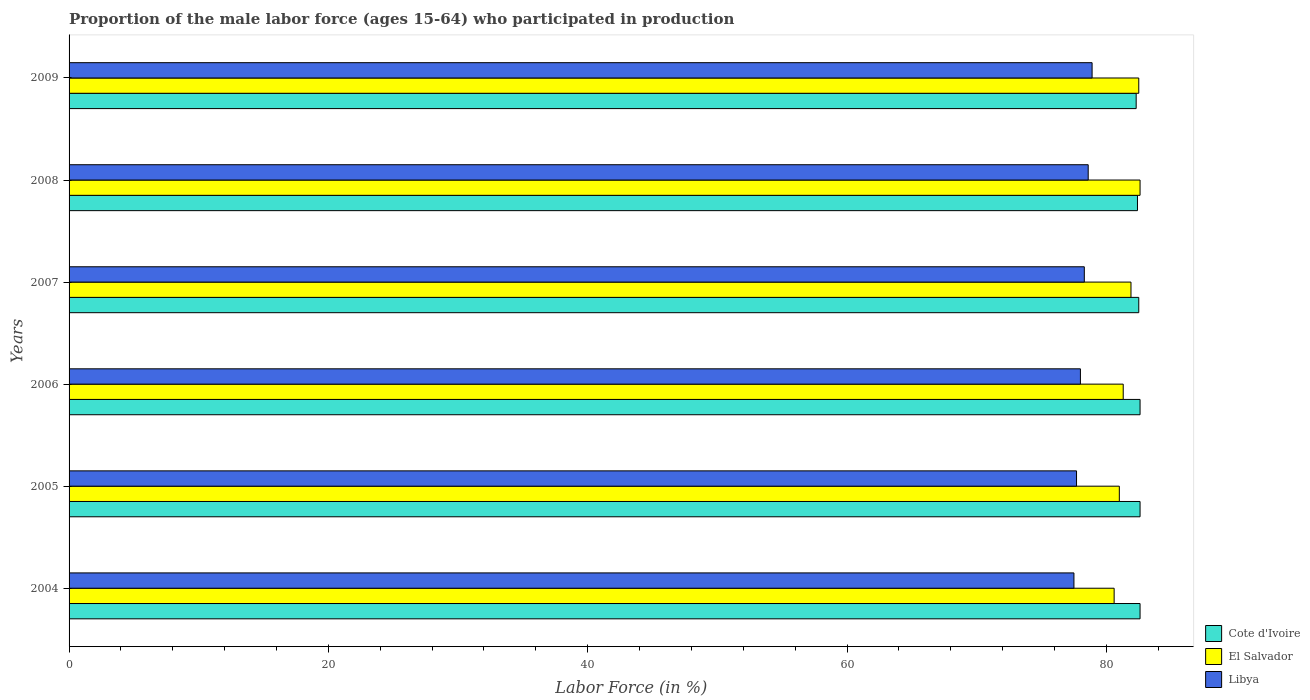How many groups of bars are there?
Give a very brief answer. 6. What is the label of the 4th group of bars from the top?
Offer a very short reply. 2006. What is the proportion of the male labor force who participated in production in Libya in 2008?
Your answer should be compact. 78.6. Across all years, what is the maximum proportion of the male labor force who participated in production in El Salvador?
Give a very brief answer. 82.6. Across all years, what is the minimum proportion of the male labor force who participated in production in Libya?
Your response must be concise. 77.5. In which year was the proportion of the male labor force who participated in production in Cote d'Ivoire minimum?
Offer a terse response. 2009. What is the total proportion of the male labor force who participated in production in Libya in the graph?
Provide a succinct answer. 469. What is the difference between the proportion of the male labor force who participated in production in Cote d'Ivoire in 2005 and that in 2008?
Your response must be concise. 0.2. What is the difference between the proportion of the male labor force who participated in production in El Salvador in 2005 and the proportion of the male labor force who participated in production in Libya in 2007?
Provide a short and direct response. 2.7. What is the average proportion of the male labor force who participated in production in El Salvador per year?
Ensure brevity in your answer.  81.65. In the year 2006, what is the difference between the proportion of the male labor force who participated in production in El Salvador and proportion of the male labor force who participated in production in Libya?
Give a very brief answer. 3.3. In how many years, is the proportion of the male labor force who participated in production in Libya greater than 48 %?
Offer a very short reply. 6. What is the ratio of the proportion of the male labor force who participated in production in Libya in 2006 to that in 2008?
Keep it short and to the point. 0.99. Is the proportion of the male labor force who participated in production in El Salvador in 2004 less than that in 2005?
Provide a short and direct response. Yes. What is the difference between the highest and the second highest proportion of the male labor force who participated in production in El Salvador?
Your response must be concise. 0.1. What is the difference between the highest and the lowest proportion of the male labor force who participated in production in Libya?
Make the answer very short. 1.4. In how many years, is the proportion of the male labor force who participated in production in Libya greater than the average proportion of the male labor force who participated in production in Libya taken over all years?
Give a very brief answer. 3. Is the sum of the proportion of the male labor force who participated in production in Libya in 2005 and 2007 greater than the maximum proportion of the male labor force who participated in production in El Salvador across all years?
Offer a very short reply. Yes. What does the 3rd bar from the top in 2006 represents?
Make the answer very short. Cote d'Ivoire. What does the 2nd bar from the bottom in 2007 represents?
Your answer should be compact. El Salvador. Is it the case that in every year, the sum of the proportion of the male labor force who participated in production in El Salvador and proportion of the male labor force who participated in production in Libya is greater than the proportion of the male labor force who participated in production in Cote d'Ivoire?
Your answer should be compact. Yes. Are all the bars in the graph horizontal?
Make the answer very short. Yes. How many years are there in the graph?
Ensure brevity in your answer.  6. Are the values on the major ticks of X-axis written in scientific E-notation?
Your response must be concise. No. Where does the legend appear in the graph?
Provide a short and direct response. Bottom right. How are the legend labels stacked?
Give a very brief answer. Vertical. What is the title of the graph?
Offer a very short reply. Proportion of the male labor force (ages 15-64) who participated in production. What is the label or title of the Y-axis?
Ensure brevity in your answer.  Years. What is the Labor Force (in %) of Cote d'Ivoire in 2004?
Ensure brevity in your answer.  82.6. What is the Labor Force (in %) in El Salvador in 2004?
Your response must be concise. 80.6. What is the Labor Force (in %) of Libya in 2004?
Ensure brevity in your answer.  77.5. What is the Labor Force (in %) of Cote d'Ivoire in 2005?
Your response must be concise. 82.6. What is the Labor Force (in %) of Libya in 2005?
Your answer should be very brief. 77.7. What is the Labor Force (in %) in Cote d'Ivoire in 2006?
Your answer should be compact. 82.6. What is the Labor Force (in %) of El Salvador in 2006?
Provide a succinct answer. 81.3. What is the Labor Force (in %) in Cote d'Ivoire in 2007?
Ensure brevity in your answer.  82.5. What is the Labor Force (in %) of El Salvador in 2007?
Offer a very short reply. 81.9. What is the Labor Force (in %) of Libya in 2007?
Provide a short and direct response. 78.3. What is the Labor Force (in %) in Cote d'Ivoire in 2008?
Provide a succinct answer. 82.4. What is the Labor Force (in %) of El Salvador in 2008?
Offer a terse response. 82.6. What is the Labor Force (in %) in Libya in 2008?
Offer a very short reply. 78.6. What is the Labor Force (in %) in Cote d'Ivoire in 2009?
Provide a succinct answer. 82.3. What is the Labor Force (in %) of El Salvador in 2009?
Your answer should be compact. 82.5. What is the Labor Force (in %) of Libya in 2009?
Give a very brief answer. 78.9. Across all years, what is the maximum Labor Force (in %) in Cote d'Ivoire?
Your answer should be very brief. 82.6. Across all years, what is the maximum Labor Force (in %) in El Salvador?
Your answer should be very brief. 82.6. Across all years, what is the maximum Labor Force (in %) in Libya?
Offer a terse response. 78.9. Across all years, what is the minimum Labor Force (in %) in Cote d'Ivoire?
Offer a terse response. 82.3. Across all years, what is the minimum Labor Force (in %) in El Salvador?
Provide a short and direct response. 80.6. Across all years, what is the minimum Labor Force (in %) in Libya?
Keep it short and to the point. 77.5. What is the total Labor Force (in %) in Cote d'Ivoire in the graph?
Provide a short and direct response. 495. What is the total Labor Force (in %) of El Salvador in the graph?
Provide a short and direct response. 489.9. What is the total Labor Force (in %) of Libya in the graph?
Keep it short and to the point. 469. What is the difference between the Labor Force (in %) of El Salvador in 2004 and that in 2006?
Your response must be concise. -0.7. What is the difference between the Labor Force (in %) of Libya in 2004 and that in 2006?
Ensure brevity in your answer.  -0.5. What is the difference between the Labor Force (in %) of El Salvador in 2004 and that in 2007?
Provide a short and direct response. -1.3. What is the difference between the Labor Force (in %) of Libya in 2004 and that in 2007?
Offer a terse response. -0.8. What is the difference between the Labor Force (in %) in Cote d'Ivoire in 2004 and that in 2008?
Offer a very short reply. 0.2. What is the difference between the Labor Force (in %) in Libya in 2004 and that in 2008?
Make the answer very short. -1.1. What is the difference between the Labor Force (in %) of Cote d'Ivoire in 2004 and that in 2009?
Your answer should be compact. 0.3. What is the difference between the Labor Force (in %) of El Salvador in 2004 and that in 2009?
Make the answer very short. -1.9. What is the difference between the Labor Force (in %) in Libya in 2004 and that in 2009?
Give a very brief answer. -1.4. What is the difference between the Labor Force (in %) of Cote d'Ivoire in 2005 and that in 2006?
Offer a terse response. 0. What is the difference between the Labor Force (in %) in Libya in 2005 and that in 2006?
Provide a short and direct response. -0.3. What is the difference between the Labor Force (in %) in Cote d'Ivoire in 2005 and that in 2007?
Make the answer very short. 0.1. What is the difference between the Labor Force (in %) of El Salvador in 2005 and that in 2007?
Give a very brief answer. -0.9. What is the difference between the Labor Force (in %) in Libya in 2005 and that in 2007?
Ensure brevity in your answer.  -0.6. What is the difference between the Labor Force (in %) in Cote d'Ivoire in 2005 and that in 2008?
Your response must be concise. 0.2. What is the difference between the Labor Force (in %) in El Salvador in 2005 and that in 2008?
Offer a very short reply. -1.6. What is the difference between the Labor Force (in %) in Libya in 2005 and that in 2008?
Offer a very short reply. -0.9. What is the difference between the Labor Force (in %) of El Salvador in 2005 and that in 2009?
Your response must be concise. -1.5. What is the difference between the Labor Force (in %) of Libya in 2006 and that in 2007?
Make the answer very short. -0.3. What is the difference between the Labor Force (in %) of El Salvador in 2006 and that in 2008?
Make the answer very short. -1.3. What is the difference between the Labor Force (in %) of Cote d'Ivoire in 2006 and that in 2009?
Give a very brief answer. 0.3. What is the difference between the Labor Force (in %) in El Salvador in 2006 and that in 2009?
Give a very brief answer. -1.2. What is the difference between the Labor Force (in %) of Cote d'Ivoire in 2007 and that in 2008?
Make the answer very short. 0.1. What is the difference between the Labor Force (in %) of El Salvador in 2007 and that in 2009?
Make the answer very short. -0.6. What is the difference between the Labor Force (in %) of Libya in 2007 and that in 2009?
Offer a terse response. -0.6. What is the difference between the Labor Force (in %) in Cote d'Ivoire in 2008 and that in 2009?
Provide a short and direct response. 0.1. What is the difference between the Labor Force (in %) of Libya in 2008 and that in 2009?
Ensure brevity in your answer.  -0.3. What is the difference between the Labor Force (in %) of Cote d'Ivoire in 2004 and the Labor Force (in %) of El Salvador in 2005?
Make the answer very short. 1.6. What is the difference between the Labor Force (in %) of Cote d'Ivoire in 2004 and the Labor Force (in %) of Libya in 2005?
Give a very brief answer. 4.9. What is the difference between the Labor Force (in %) in El Salvador in 2004 and the Labor Force (in %) in Libya in 2005?
Your response must be concise. 2.9. What is the difference between the Labor Force (in %) in Cote d'Ivoire in 2004 and the Labor Force (in %) in El Salvador in 2006?
Provide a succinct answer. 1.3. What is the difference between the Labor Force (in %) of El Salvador in 2004 and the Labor Force (in %) of Libya in 2006?
Make the answer very short. 2.6. What is the difference between the Labor Force (in %) of Cote d'Ivoire in 2004 and the Labor Force (in %) of El Salvador in 2007?
Make the answer very short. 0.7. What is the difference between the Labor Force (in %) in Cote d'Ivoire in 2004 and the Labor Force (in %) in Libya in 2007?
Ensure brevity in your answer.  4.3. What is the difference between the Labor Force (in %) of El Salvador in 2004 and the Labor Force (in %) of Libya in 2007?
Offer a terse response. 2.3. What is the difference between the Labor Force (in %) of Cote d'Ivoire in 2004 and the Labor Force (in %) of El Salvador in 2008?
Offer a terse response. 0. What is the difference between the Labor Force (in %) of El Salvador in 2004 and the Labor Force (in %) of Libya in 2008?
Offer a terse response. 2. What is the difference between the Labor Force (in %) in Cote d'Ivoire in 2004 and the Labor Force (in %) in El Salvador in 2009?
Provide a succinct answer. 0.1. What is the difference between the Labor Force (in %) of El Salvador in 2004 and the Labor Force (in %) of Libya in 2009?
Give a very brief answer. 1.7. What is the difference between the Labor Force (in %) in Cote d'Ivoire in 2005 and the Labor Force (in %) in El Salvador in 2006?
Provide a short and direct response. 1.3. What is the difference between the Labor Force (in %) in Cote d'Ivoire in 2005 and the Labor Force (in %) in Libya in 2008?
Keep it short and to the point. 4. What is the difference between the Labor Force (in %) of Cote d'Ivoire in 2005 and the Labor Force (in %) of Libya in 2009?
Provide a short and direct response. 3.7. What is the difference between the Labor Force (in %) of Cote d'Ivoire in 2006 and the Labor Force (in %) of El Salvador in 2007?
Keep it short and to the point. 0.7. What is the difference between the Labor Force (in %) of Cote d'Ivoire in 2006 and the Labor Force (in %) of El Salvador in 2008?
Keep it short and to the point. 0. What is the difference between the Labor Force (in %) of El Salvador in 2006 and the Labor Force (in %) of Libya in 2008?
Ensure brevity in your answer.  2.7. What is the difference between the Labor Force (in %) of Cote d'Ivoire in 2006 and the Labor Force (in %) of Libya in 2009?
Ensure brevity in your answer.  3.7. What is the difference between the Labor Force (in %) in Cote d'Ivoire in 2007 and the Labor Force (in %) in El Salvador in 2008?
Your response must be concise. -0.1. What is the difference between the Labor Force (in %) of Cote d'Ivoire in 2007 and the Labor Force (in %) of Libya in 2008?
Offer a terse response. 3.9. What is the difference between the Labor Force (in %) of El Salvador in 2007 and the Labor Force (in %) of Libya in 2009?
Give a very brief answer. 3. What is the difference between the Labor Force (in %) in Cote d'Ivoire in 2008 and the Labor Force (in %) in El Salvador in 2009?
Provide a short and direct response. -0.1. What is the difference between the Labor Force (in %) in Cote d'Ivoire in 2008 and the Labor Force (in %) in Libya in 2009?
Your answer should be compact. 3.5. What is the average Labor Force (in %) in Cote d'Ivoire per year?
Your response must be concise. 82.5. What is the average Labor Force (in %) in El Salvador per year?
Your response must be concise. 81.65. What is the average Labor Force (in %) in Libya per year?
Provide a short and direct response. 78.17. In the year 2004, what is the difference between the Labor Force (in %) in El Salvador and Labor Force (in %) in Libya?
Your answer should be very brief. 3.1. In the year 2006, what is the difference between the Labor Force (in %) in Cote d'Ivoire and Labor Force (in %) in El Salvador?
Your answer should be compact. 1.3. In the year 2006, what is the difference between the Labor Force (in %) in Cote d'Ivoire and Labor Force (in %) in Libya?
Your answer should be very brief. 4.6. In the year 2007, what is the difference between the Labor Force (in %) of Cote d'Ivoire and Labor Force (in %) of Libya?
Keep it short and to the point. 4.2. In the year 2009, what is the difference between the Labor Force (in %) in Cote d'Ivoire and Labor Force (in %) in El Salvador?
Your response must be concise. -0.2. In the year 2009, what is the difference between the Labor Force (in %) in Cote d'Ivoire and Labor Force (in %) in Libya?
Your answer should be very brief. 3.4. In the year 2009, what is the difference between the Labor Force (in %) in El Salvador and Labor Force (in %) in Libya?
Your answer should be very brief. 3.6. What is the ratio of the Labor Force (in %) in Cote d'Ivoire in 2004 to that in 2005?
Make the answer very short. 1. What is the ratio of the Labor Force (in %) in El Salvador in 2004 to that in 2005?
Provide a succinct answer. 1. What is the ratio of the Labor Force (in %) of Libya in 2004 to that in 2005?
Make the answer very short. 1. What is the ratio of the Labor Force (in %) in Cote d'Ivoire in 2004 to that in 2006?
Make the answer very short. 1. What is the ratio of the Labor Force (in %) of El Salvador in 2004 to that in 2006?
Keep it short and to the point. 0.99. What is the ratio of the Labor Force (in %) of Libya in 2004 to that in 2006?
Offer a very short reply. 0.99. What is the ratio of the Labor Force (in %) of El Salvador in 2004 to that in 2007?
Ensure brevity in your answer.  0.98. What is the ratio of the Labor Force (in %) in El Salvador in 2004 to that in 2008?
Keep it short and to the point. 0.98. What is the ratio of the Labor Force (in %) of Cote d'Ivoire in 2004 to that in 2009?
Provide a succinct answer. 1. What is the ratio of the Labor Force (in %) of Libya in 2004 to that in 2009?
Make the answer very short. 0.98. What is the ratio of the Labor Force (in %) in Cote d'Ivoire in 2005 to that in 2006?
Your response must be concise. 1. What is the ratio of the Labor Force (in %) of El Salvador in 2005 to that in 2006?
Provide a short and direct response. 1. What is the ratio of the Labor Force (in %) in Libya in 2005 to that in 2006?
Keep it short and to the point. 1. What is the ratio of the Labor Force (in %) of Cote d'Ivoire in 2005 to that in 2007?
Keep it short and to the point. 1. What is the ratio of the Labor Force (in %) of Libya in 2005 to that in 2007?
Provide a short and direct response. 0.99. What is the ratio of the Labor Force (in %) in Cote d'Ivoire in 2005 to that in 2008?
Your answer should be compact. 1. What is the ratio of the Labor Force (in %) of El Salvador in 2005 to that in 2008?
Ensure brevity in your answer.  0.98. What is the ratio of the Labor Force (in %) of Libya in 2005 to that in 2008?
Your answer should be very brief. 0.99. What is the ratio of the Labor Force (in %) in Cote d'Ivoire in 2005 to that in 2009?
Provide a short and direct response. 1. What is the ratio of the Labor Force (in %) of El Salvador in 2005 to that in 2009?
Provide a short and direct response. 0.98. What is the ratio of the Labor Force (in %) of El Salvador in 2006 to that in 2007?
Provide a succinct answer. 0.99. What is the ratio of the Labor Force (in %) of Libya in 2006 to that in 2007?
Your response must be concise. 1. What is the ratio of the Labor Force (in %) of Cote d'Ivoire in 2006 to that in 2008?
Ensure brevity in your answer.  1. What is the ratio of the Labor Force (in %) in El Salvador in 2006 to that in 2008?
Keep it short and to the point. 0.98. What is the ratio of the Labor Force (in %) in Cote d'Ivoire in 2006 to that in 2009?
Your answer should be compact. 1. What is the ratio of the Labor Force (in %) in El Salvador in 2006 to that in 2009?
Offer a very short reply. 0.99. What is the ratio of the Labor Force (in %) of Libya in 2006 to that in 2009?
Make the answer very short. 0.99. What is the ratio of the Labor Force (in %) of El Salvador in 2007 to that in 2008?
Keep it short and to the point. 0.99. What is the ratio of the Labor Force (in %) in Libya in 2007 to that in 2008?
Your response must be concise. 1. What is the ratio of the Labor Force (in %) of Cote d'Ivoire in 2007 to that in 2009?
Offer a terse response. 1. What is the ratio of the Labor Force (in %) of El Salvador in 2007 to that in 2009?
Give a very brief answer. 0.99. What is the ratio of the Labor Force (in %) in Cote d'Ivoire in 2008 to that in 2009?
Your answer should be compact. 1. What is the difference between the highest and the second highest Labor Force (in %) in Cote d'Ivoire?
Your response must be concise. 0. What is the difference between the highest and the lowest Labor Force (in %) of Cote d'Ivoire?
Offer a terse response. 0.3. What is the difference between the highest and the lowest Labor Force (in %) of El Salvador?
Your answer should be very brief. 2. 